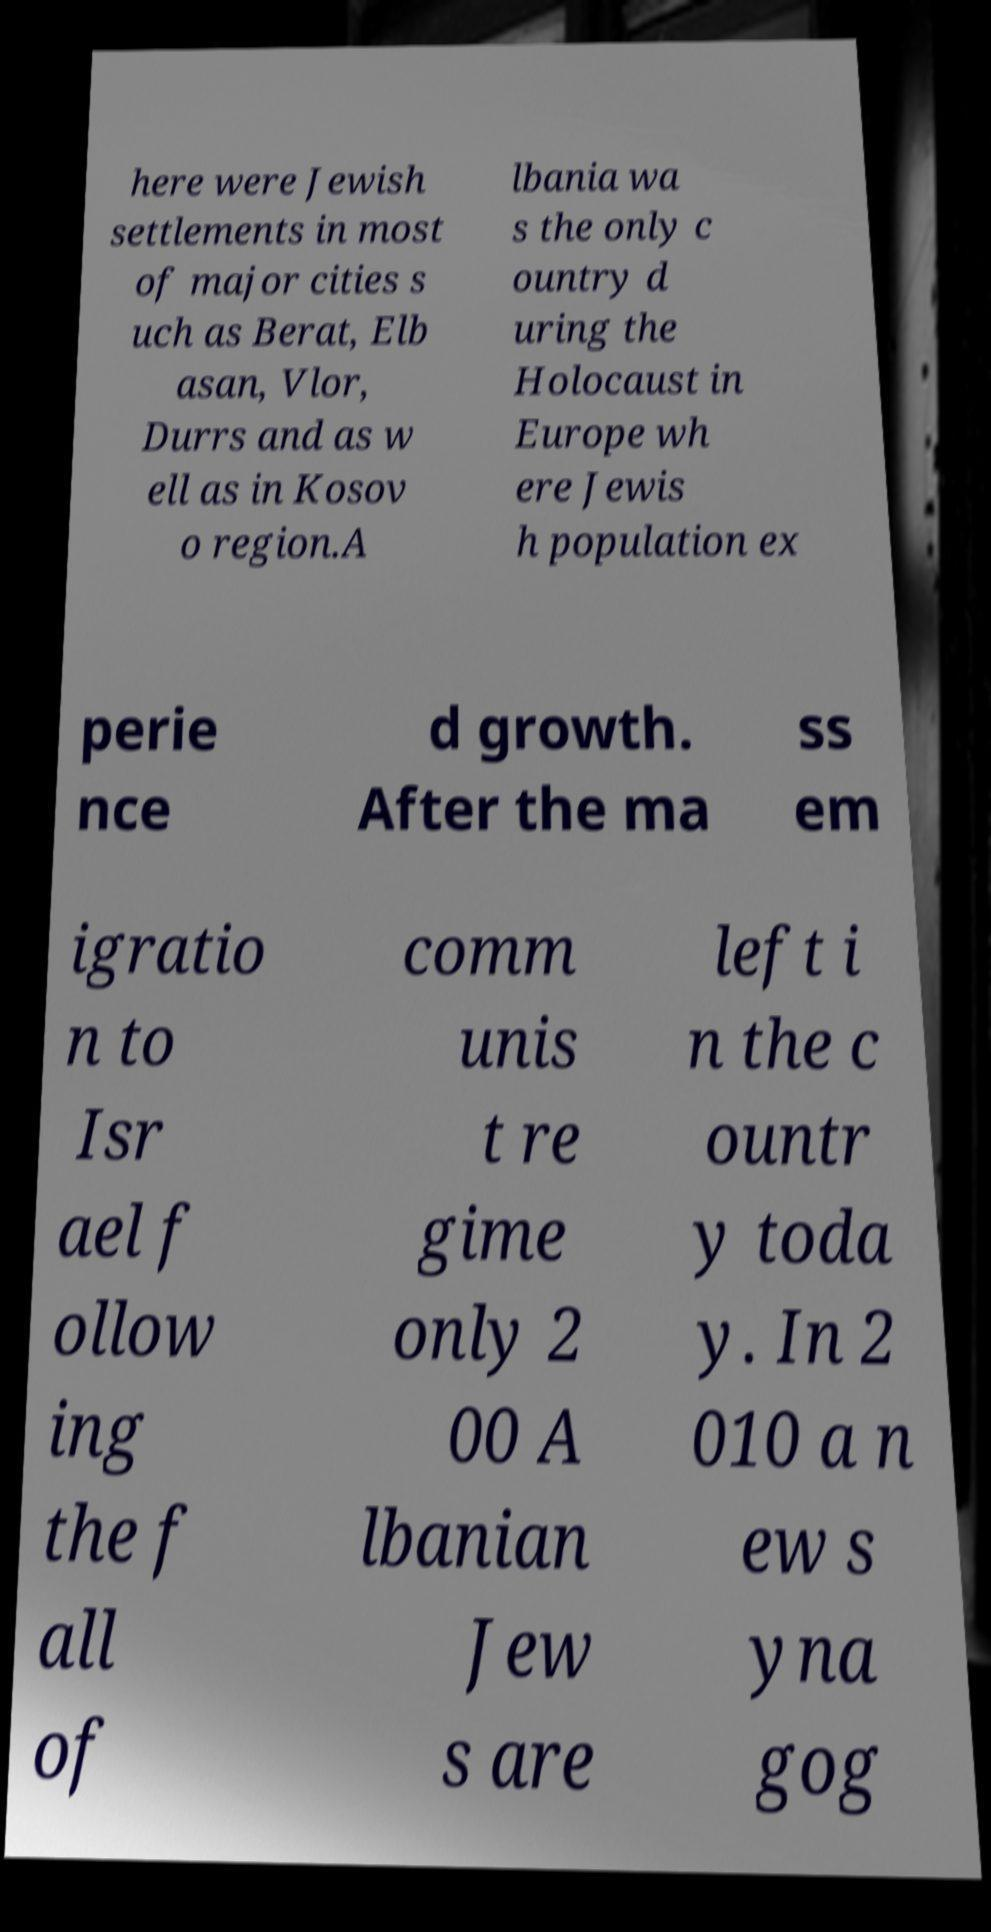What messages or text are displayed in this image? I need them in a readable, typed format. here were Jewish settlements in most of major cities s uch as Berat, Elb asan, Vlor, Durrs and as w ell as in Kosov o region.A lbania wa s the only c ountry d uring the Holocaust in Europe wh ere Jewis h population ex perie nce d growth. After the ma ss em igratio n to Isr ael f ollow ing the f all of comm unis t re gime only 2 00 A lbanian Jew s are left i n the c ountr y toda y. In 2 010 a n ew s yna gog 